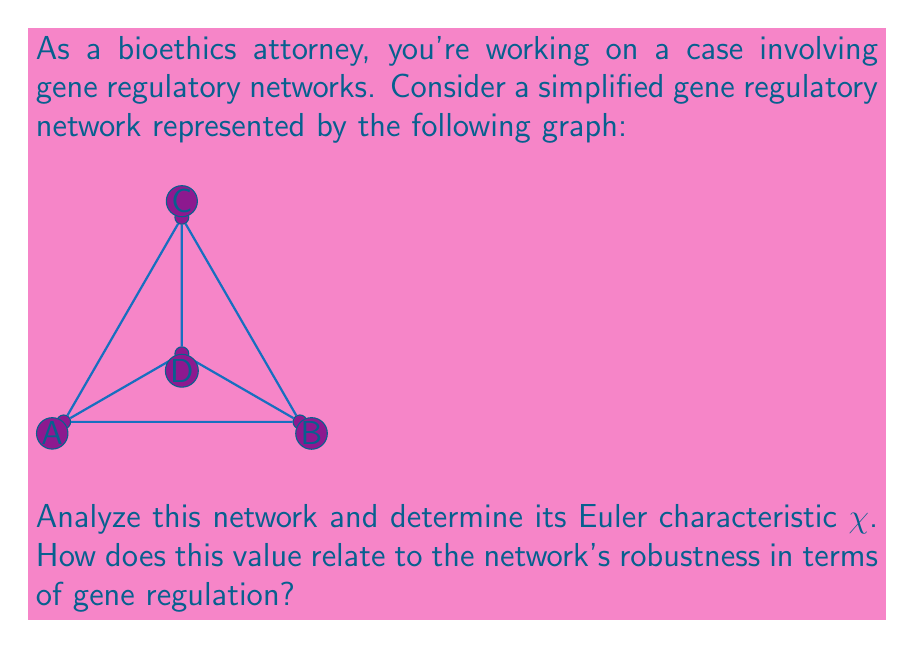Help me with this question. To solve this problem, we'll follow these steps:

1) First, let's recall the formula for the Euler characteristic:
   $$ \chi = V - E + F $$
   where V is the number of vertices, E is the number of edges, and F is the number of faces.

2) Count the components:
   - Vertices (V): There are 4 vertices (A, B, C, D)
   - Edges (E): There are 6 edges (AB, BC, CA, AD, BD, CD)
   - Faces (F): There are 4 faces (3 triangles + 1 outer face)

3) Apply the formula:
   $$ \chi = 4 - 6 + 4 = 2 $$

4) Interpret the result:
   The Euler characteristic of 2 indicates that this network is topologically equivalent to a sphere. In gene regulatory networks, this property suggests:

   a) Robustness: The network has a high degree of connectivity, which can provide redundancy in gene regulation pathways.
   
   b) Stability: The spherical topology implies that the network is resistant to small perturbations, maintaining overall function even if individual connections are disrupted.
   
   c) Modularity: The presence of multiple faces (regulatory modules) allows for complex, coordinated gene expression patterns.

5) Bioethical implications:
   As a bioethics attorney, understanding this topological property is crucial when considering the ethical implications of manipulating such networks. The robustness suggested by the Euler characteristic of 2 implies that interventions in this network might have widespread and potentially unpredictable effects, necessitating careful ethical consideration in genetic engineering or therapeutic approaches.
Answer: $\chi = 2$, indicating sphere-like topology and suggesting network robustness. 